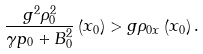Convert formula to latex. <formula><loc_0><loc_0><loc_500><loc_500>\frac { g ^ { 2 } \rho _ { 0 } ^ { 2 } } { \gamma p _ { 0 } + B _ { 0 } ^ { 2 } } \left ( x _ { 0 } \right ) > g \rho _ { 0 x } \left ( x _ { 0 } \right ) .</formula> 